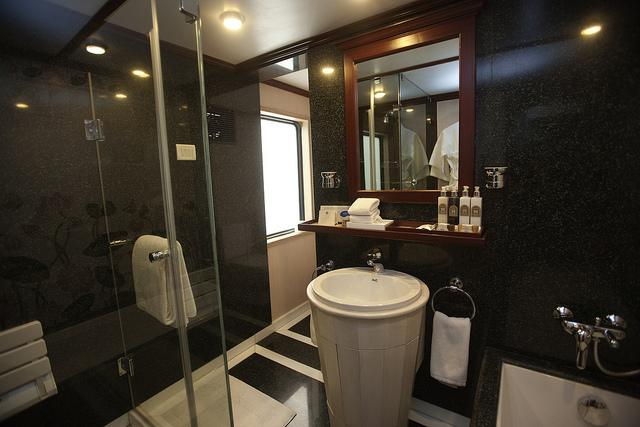What is most likely outside the doorway? Please explain your reasoning. bedroom. There is likely a bedroom attached to this bathroom. 